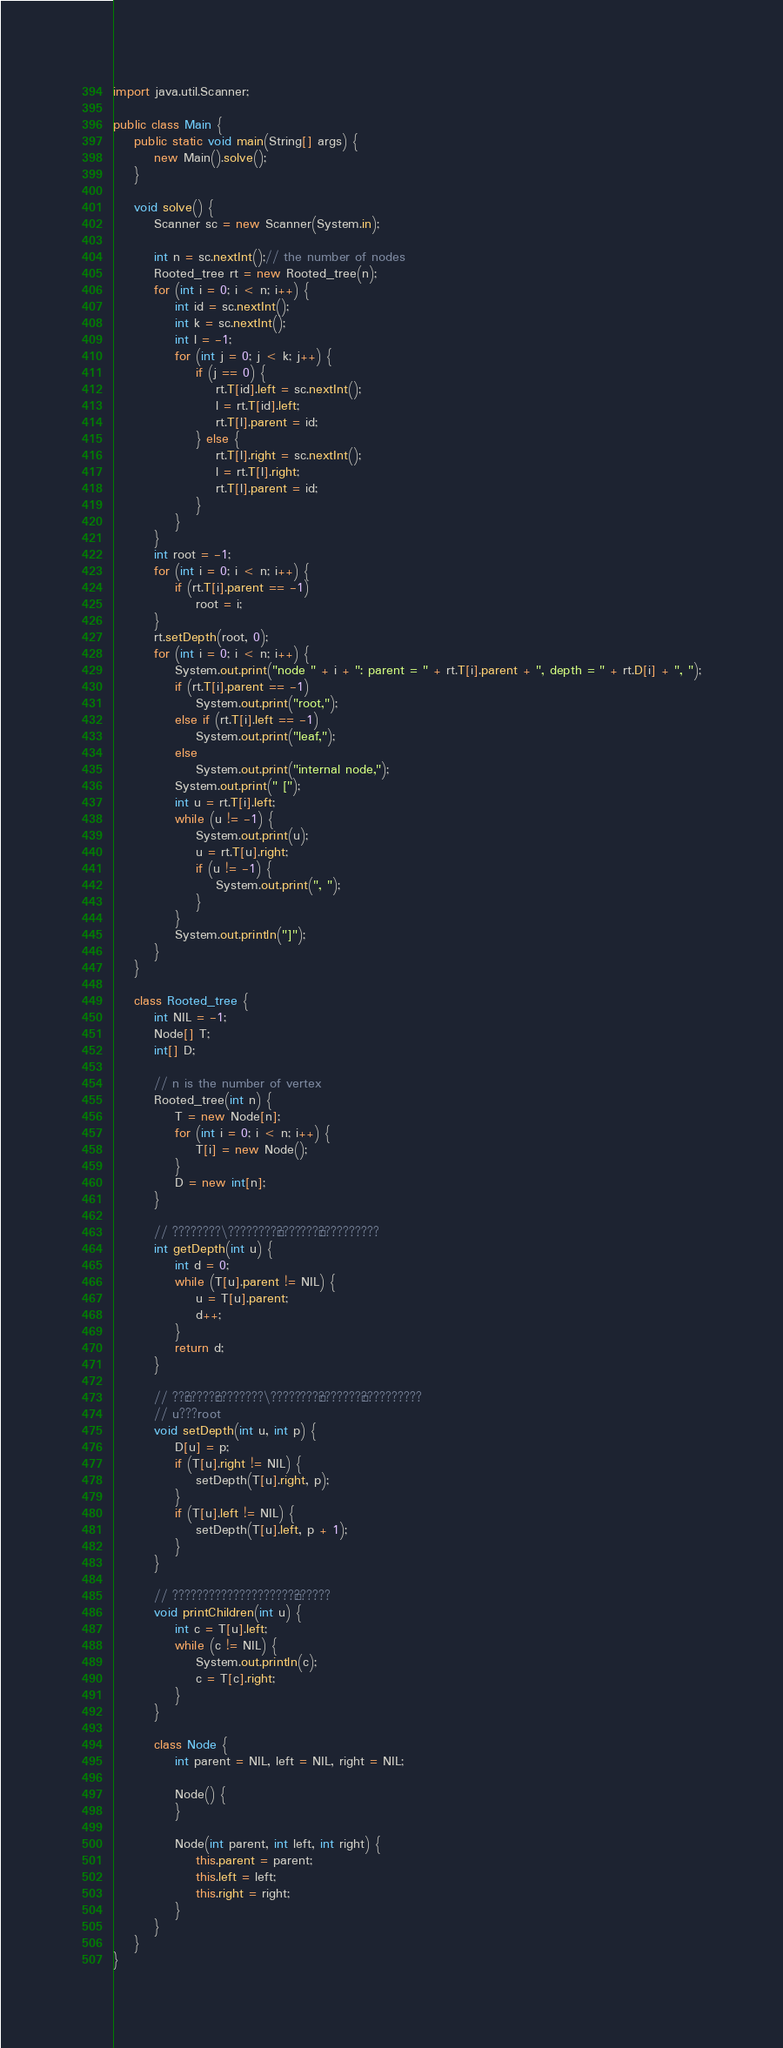<code> <loc_0><loc_0><loc_500><loc_500><_Java_>
import java.util.Scanner;

public class Main {
	public static void main(String[] args) {
		new Main().solve();
	}

	void solve() {
		Scanner sc = new Scanner(System.in);

		int n = sc.nextInt();// the number of nodes
		Rooted_tree rt = new Rooted_tree(n);
		for (int i = 0; i < n; i++) {
			int id = sc.nextInt();
			int k = sc.nextInt();
			int l = -1;
			for (int j = 0; j < k; j++) {
				if (j == 0) {
					rt.T[id].left = sc.nextInt();
					l = rt.T[id].left;
					rt.T[l].parent = id;
				} else {
					rt.T[l].right = sc.nextInt();
					l = rt.T[l].right;
					rt.T[l].parent = id;
				}
			}
		}
		int root = -1;
		for (int i = 0; i < n; i++) {
			if (rt.T[i].parent == -1)
				root = i;
		}
		rt.setDepth(root, 0);
		for (int i = 0; i < n; i++) {
			System.out.print("node " + i + ": parent = " + rt.T[i].parent + ", depth = " + rt.D[i] + ", ");
			if (rt.T[i].parent == -1)
				System.out.print("root,");
			else if (rt.T[i].left == -1)
				System.out.print("leaf,");
			else
				System.out.print("internal node,");
			System.out.print(" [");
			int u = rt.T[i].left;
			while (u != -1) {
				System.out.print(u);
				u = rt.T[u].right;
				if (u != -1) {
					System.out.print(", ");
				}
			}
			System.out.println("]");
		}
	}

	class Rooted_tree {
		int NIL = -1;
		Node[] T;
		int[] D;

		// n is the number of vertex
		Rooted_tree(int n) {
			T = new Node[n];
			for (int i = 0; i < n; i++) {
				T[i] = new Node();
			}
			D = new int[n];
		}

		// ????????\????????±???????±??????????
		int getDepth(int u) {
			int d = 0;
			while (T[u].parent != NIL) {
				u = T[u].parent;
				d++;
			}
			return d;
		}

		// ??¨?????¨????????\????????±???????±??????????
		// u???root
		void setDepth(int u, int p) {
			D[u] = p;
			if (T[u].right != NIL) {
				setDepth(T[u].right, p);
			}
			if (T[u].left != NIL) {
				setDepth(T[u].left, p + 1);
			}
		}

		// ????????????????????¨??????
		void printChildren(int u) {
			int c = T[u].left;
			while (c != NIL) {
				System.out.println(c);
				c = T[c].right;
			}
		}

		class Node {
			int parent = NIL, left = NIL, right = NIL;

			Node() {
			}

			Node(int parent, int left, int right) {
				this.parent = parent;
				this.left = left;
				this.right = right;
			}
		}
	}
}</code> 